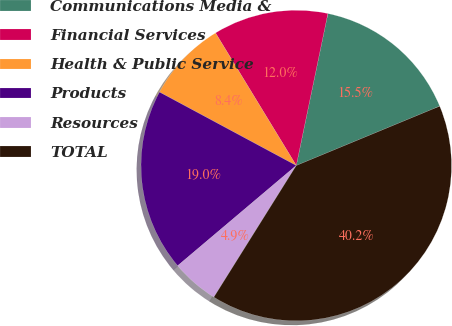Convert chart. <chart><loc_0><loc_0><loc_500><loc_500><pie_chart><fcel>Communications Media &<fcel>Financial Services<fcel>Health & Public Service<fcel>Products<fcel>Resources<fcel>TOTAL<nl><fcel>15.49%<fcel>11.97%<fcel>8.45%<fcel>19.01%<fcel>4.93%<fcel>40.15%<nl></chart> 